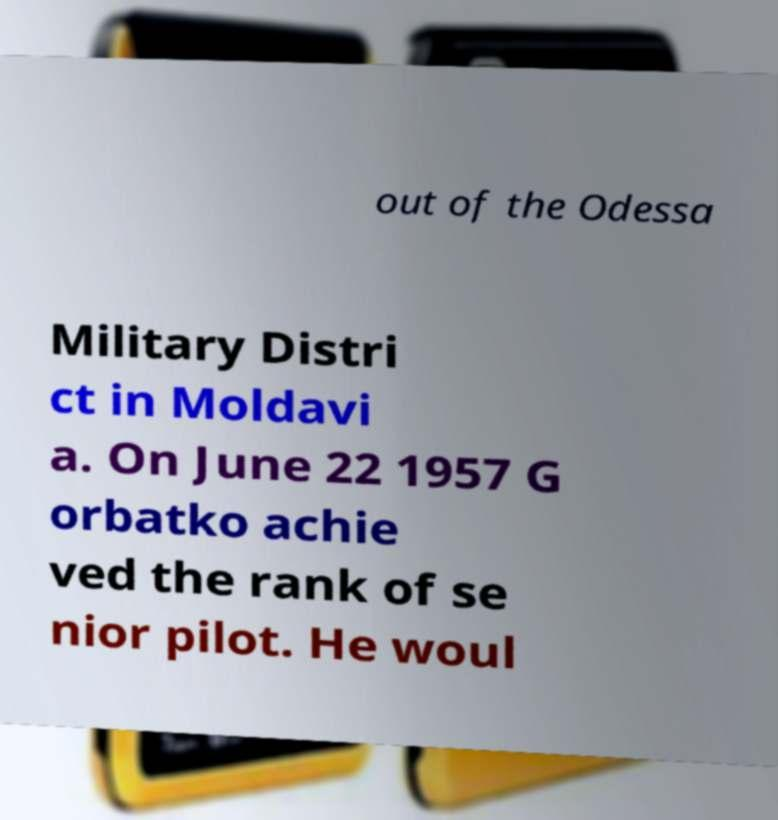For documentation purposes, I need the text within this image transcribed. Could you provide that? out of the Odessa Military Distri ct in Moldavi a. On June 22 1957 G orbatko achie ved the rank of se nior pilot. He woul 